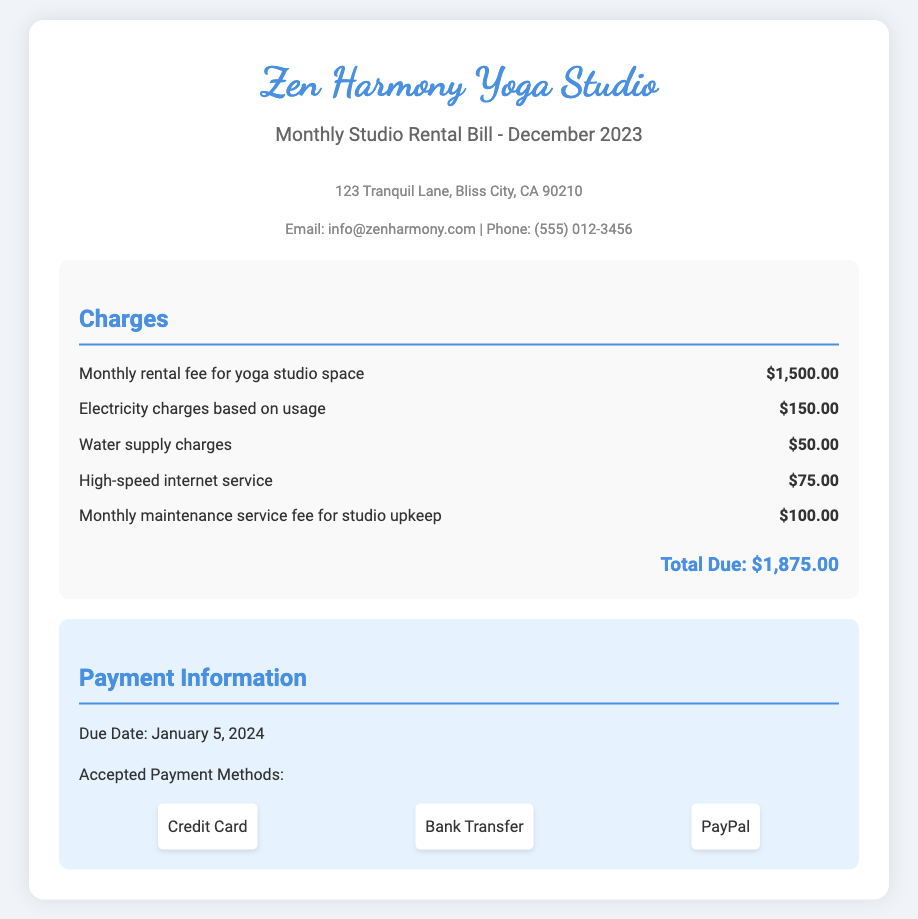What is the total amount due? The total amount due is the sum of all charges listed in the document.
Answer: $1,875.00 What is the due date for payment? The document specifies a due date for payment.
Answer: January 5, 2024 How much is the monthly rental fee for the yoga studio space? The document lists the monthly rental fee separately.
Answer: $1,500.00 What is the charge for high-speed internet service? The document includes specific charges for services, including internet.
Answer: $75.00 What are the accepted payment methods? The document lists several payment methods available for settling the bill.
Answer: Credit Card, Bank Transfer, PayPal How much are the electricity charges? The document specifies the amount for electricity charges based on usage.
Answer: $150.00 What is the maintenance service fee for studio upkeep? The billing details refer to the maintenance service fee separately.
Answer: $100.00 What is the charge for water supply? The document includes a specific charge for water supply services.
Answer: $50.00 